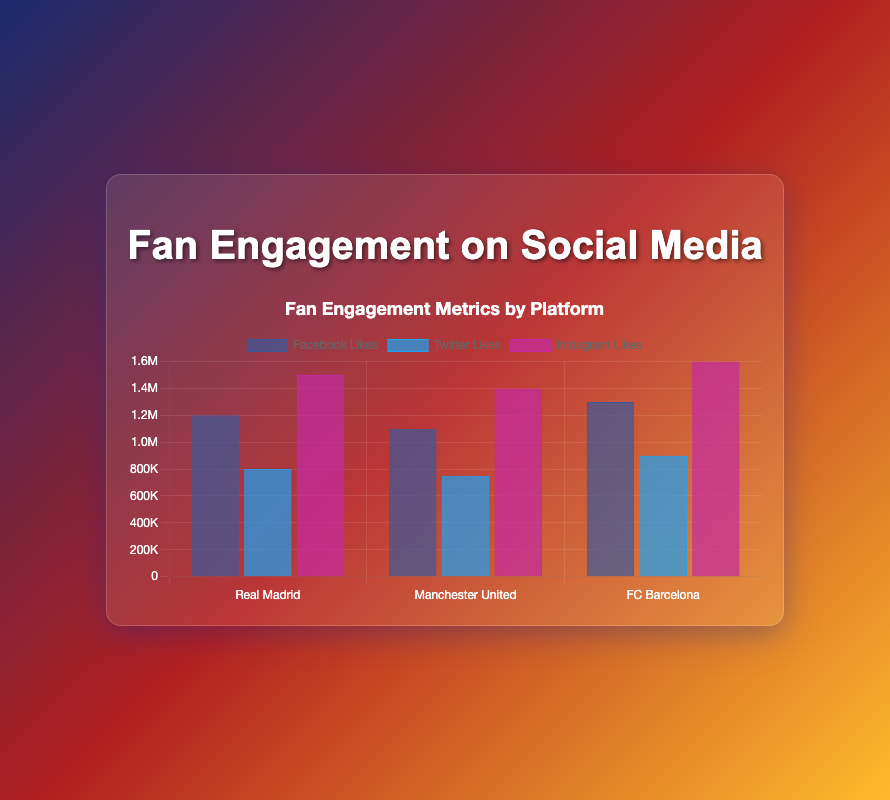Which platform has the most likes for Real Madrid? Looking at the bars for Real Madrid, we see that the Instagram bar is the highest, followed by Facebook and Twitter. Therefore, Instagram has the most likes for Real Madrid.
Answer: Instagram Which team has the highest likes on Facebook? Comparing the Facebook bars for all three teams, FC Barcelona has the highest bar, followed by Real Madrid and Manchester United. Hence, FC Barcelona has the highest likes on Facebook.
Answer: FC Barcelona What is the difference in Instagram likes between FC Barcelona and Manchester United? For Instagram, FC Barcelona has 1.6 million likes, and Manchester United has 1.4 million likes. Subtracting these gives 1.6 million - 1.4 million = 0.2 million likes.
Answer: 0.2 million Which social media platform has the least engagement for Manchester United in terms of likes? Taking a look at the bars for Manchester United across all platforms, the shortest bar is for Twitter, indicating the least likes there.
Answer: Twitter What is the total number of likes for Real Madrid across all platforms? Summing up the likes for Real Madrid: 1.2 million (Facebook) + 0.8 million (Twitter) + 1.5 million (Instagram) = 3.5 million.
Answer: 3.5 million What is the average number of Facebook likes across all teams? Adding the Facebook likes for all teams: 1.2 million (Real Madrid) + 1.1 million (Manchester United) + 1.3 million (FC Barcelona) = 3.6 million. Dividing by 3 teams, the average is 3.6 million / 3 = 1.2 million.
Answer: 1.2 million Do FC Barcelona and Manchester United have the same level of fan engagement in terms of comments on Instagram? For Instagram, FC Barcelona has 160,000 comments, and Manchester United has 140,000 comments. The bars are not equal in height, indicating different levels of engagement.
Answer: No How many more likes does Instagram have compared to Twitter for FC Barcelona? On Instagram, FC Barcelona has 1.6 million likes, while on Twitter they have 0.9 million likes. The difference is 1.6 million - 0.9 million = 0.7 million likes.
Answer: 0.7 million Which team has the highest total engagement (likes + shares + comments) on Instagram? Summing the engagement metrics on Instagram: 
- Real Madrid: 1.5M (likes) + 0.07M (shares) + 0.15M (comments) = 1.72M
- Manchester United: 1.4M (likes) + 0.065M (shares) + 0.14M (comments) = 1.605M
- FC Barcelona: 1.6M (likes) + 0.075M (shares) + 0.16M (comments) = 1.835M
FC Barcelona has the highest total engagement on Instagram.
Answer: FC Barcelona 